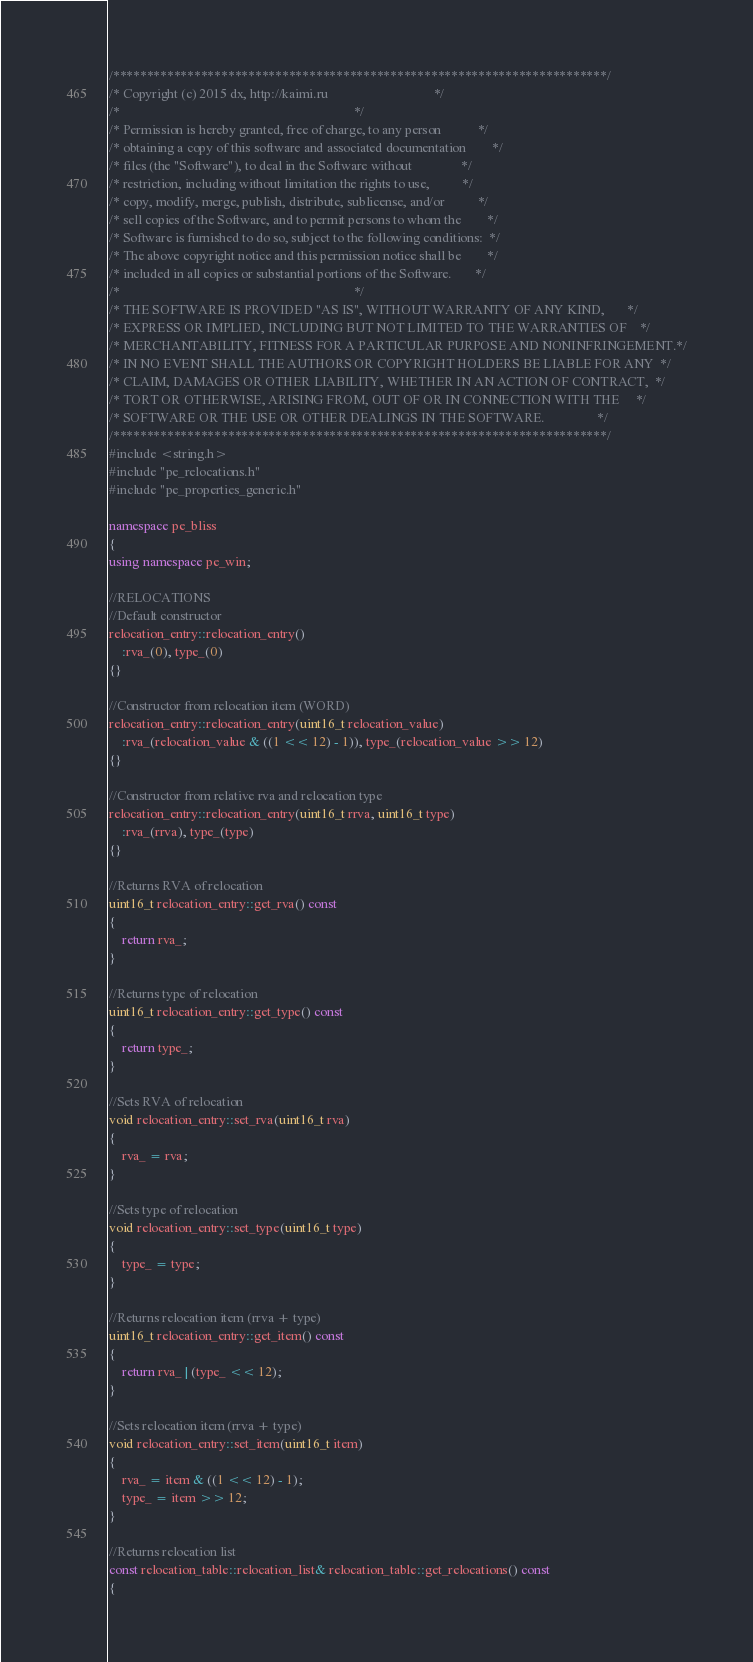Convert code to text. <code><loc_0><loc_0><loc_500><loc_500><_C++_>/*************************************************************************/
/* Copyright (c) 2015 dx, http://kaimi.ru                                */
/*                                                                       */
/* Permission is hereby granted, free of charge, to any person           */
/* obtaining a copy of this software and associated documentation        */
/* files (the "Software"), to deal in the Software without               */
/* restriction, including without limitation the rights to use,          */
/* copy, modify, merge, publish, distribute, sublicense, and/or          */
/* sell copies of the Software, and to permit persons to whom the        */
/* Software is furnished to do so, subject to the following conditions:  */
/* The above copyright notice and this permission notice shall be        */
/* included in all copies or substantial portions of the Software.       */
/*                                                                       */
/* THE SOFTWARE IS PROVIDED "AS IS", WITHOUT WARRANTY OF ANY KIND,       */
/* EXPRESS OR IMPLIED, INCLUDING BUT NOT LIMITED TO THE WARRANTIES OF    */
/* MERCHANTABILITY, FITNESS FOR A PARTICULAR PURPOSE AND NONINFRINGEMENT.*/
/* IN NO EVENT SHALL THE AUTHORS OR COPYRIGHT HOLDERS BE LIABLE FOR ANY  */
/* CLAIM, DAMAGES OR OTHER LIABILITY, WHETHER IN AN ACTION OF CONTRACT,  */
/* TORT OR OTHERWISE, ARISING FROM, OUT OF OR IN CONNECTION WITH THE     */
/* SOFTWARE OR THE USE OR OTHER DEALINGS IN THE SOFTWARE.                */
/*************************************************************************/
#include <string.h>
#include "pe_relocations.h"
#include "pe_properties_generic.h"

namespace pe_bliss
{
using namespace pe_win;

//RELOCATIONS
//Default constructor
relocation_entry::relocation_entry()
	:rva_(0), type_(0)
{}

//Constructor from relocation item (WORD)
relocation_entry::relocation_entry(uint16_t relocation_value)
	:rva_(relocation_value & ((1 << 12) - 1)), type_(relocation_value >> 12)
{}

//Constructor from relative rva and relocation type
relocation_entry::relocation_entry(uint16_t rrva, uint16_t type)
	:rva_(rrva), type_(type)
{}

//Returns RVA of relocation
uint16_t relocation_entry::get_rva() const
{
	return rva_;
}

//Returns type of relocation
uint16_t relocation_entry::get_type() const
{
	return type_;
}

//Sets RVA of relocation
void relocation_entry::set_rva(uint16_t rva)
{
	rva_ = rva;
}

//Sets type of relocation
void relocation_entry::set_type(uint16_t type)
{
	type_ = type;
}

//Returns relocation item (rrva + type)
uint16_t relocation_entry::get_item() const
{
	return rva_ | (type_ << 12);
}

//Sets relocation item (rrva + type)
void relocation_entry::set_item(uint16_t item)
{
	rva_ = item & ((1 << 12) - 1);
	type_ = item >> 12;
}

//Returns relocation list
const relocation_table::relocation_list& relocation_table::get_relocations() const
{</code> 